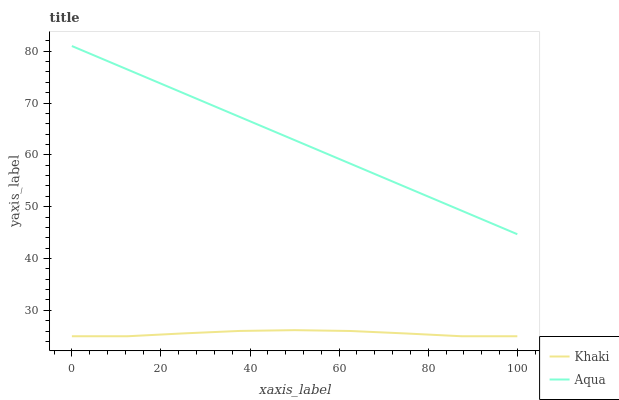Does Khaki have the minimum area under the curve?
Answer yes or no. Yes. Does Aqua have the maximum area under the curve?
Answer yes or no. Yes. Does Aqua have the minimum area under the curve?
Answer yes or no. No. Is Aqua the smoothest?
Answer yes or no. Yes. Is Khaki the roughest?
Answer yes or no. Yes. Is Aqua the roughest?
Answer yes or no. No. Does Khaki have the lowest value?
Answer yes or no. Yes. Does Aqua have the lowest value?
Answer yes or no. No. Does Aqua have the highest value?
Answer yes or no. Yes. Is Khaki less than Aqua?
Answer yes or no. Yes. Is Aqua greater than Khaki?
Answer yes or no. Yes. Does Khaki intersect Aqua?
Answer yes or no. No. 